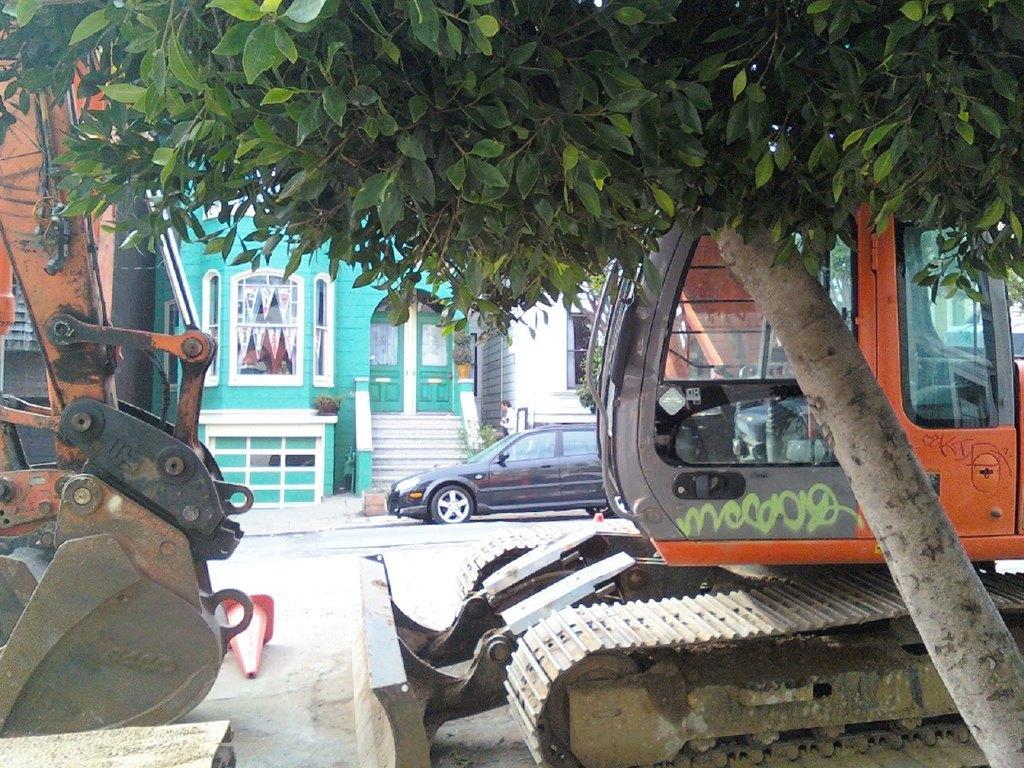Could you give a brief overview of what you see in this image? In this image there are machines. There is a car. There is a building. There is a tree on the right side. 